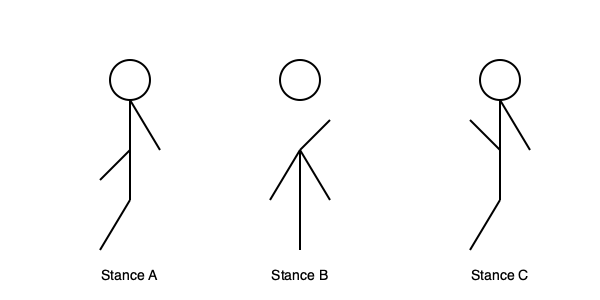Based on the stick figure diagrams representing three different defensive stances (A, B, and C), which stance would likely provide the best balance and readiness for quick movement in multiple directions during a self-defense situation? To determine the most effective defensive stance, we need to analyze each stance based on key factors:

1. Stance A:
   - Feet are positioned at different distances from the centerline
   - Upper body is slightly tilted
   - Arms are asymmetrically positioned
   
   This stance may offer good lateral movement but might be less stable for front-to-back motion.

2. Stance B:
   - Feet are shoulder-width apart
   - Body is upright
   - Arms are raised and symmetrical
   
   This stance provides a balanced foundation and allows for quick movement in multiple directions.

3. Stance C:
   - Similar to Stance A, but with reversed arm positions
   - Feet are at different distances from the centerline
   - Upper body is slightly tilted
   
   This stance also favors lateral movement but may be less stable for front-to-back motion.

Stance B offers the most balanced position:
- The shoulder-width foot placement provides a stable base.
- The upright posture allows for quick weight shifts in any direction.
- The symmetrical arm position offers equal protection and striking ability on both sides.

These characteristics make Stance B the most versatile for reacting to various attacks and transitioning into offensive movements if necessary.
Answer: Stance B 